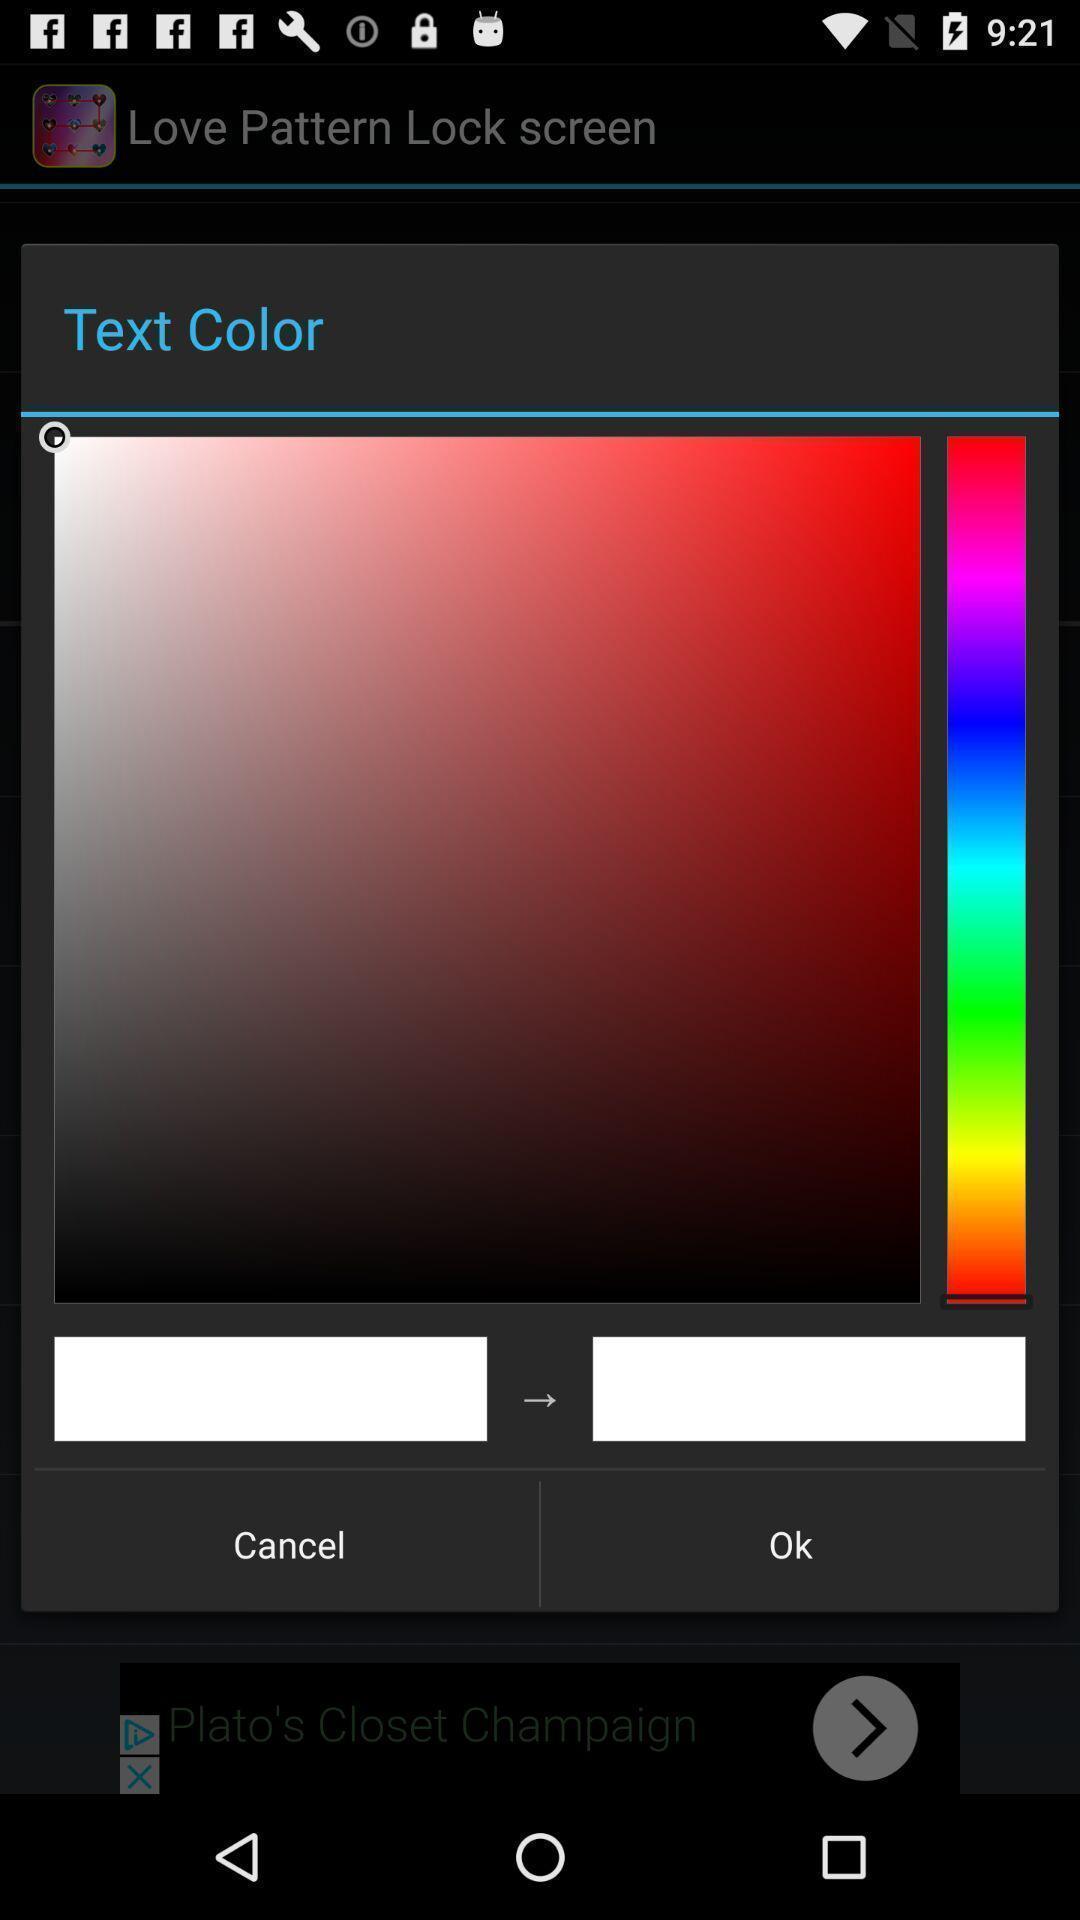Describe the content in this image. Pop up displaying multiple shades of colours. 